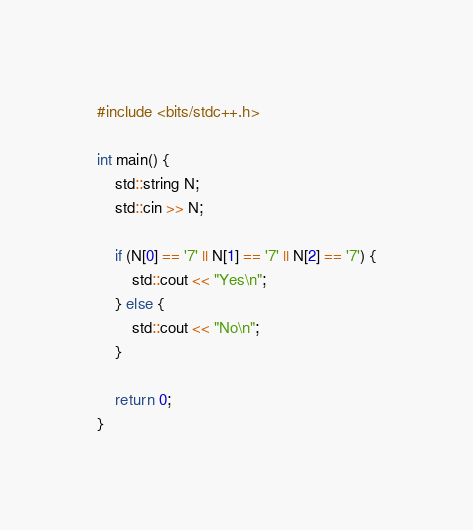Convert code to text. <code><loc_0><loc_0><loc_500><loc_500><_C_>#include <bits/stdc++.h>

int main() {
    std::string N;
    std::cin >> N;

    if (N[0] == '7' || N[1] == '7' || N[2] == '7') {
        std::cout << "Yes\n";
    } else {
        std::cout << "No\n";
    }    

    return 0;
}
</code> 